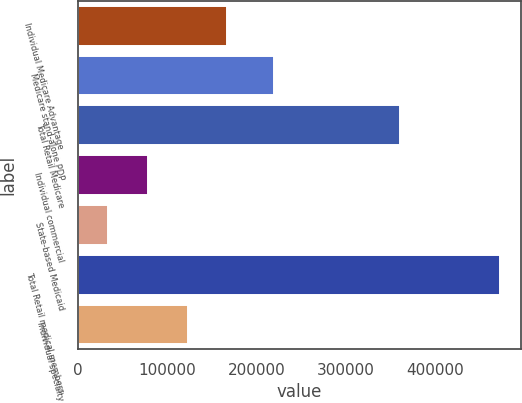<chart> <loc_0><loc_0><loc_500><loc_500><bar_chart><fcel>Individual Medicare Advantage<fcel>Medicare stand-alone PDP<fcel>Total Retail Medicare<fcel>Individual commercial<fcel>State-based Medicaid<fcel>Total Retail medical members<fcel>Individual specialty<nl><fcel>166460<fcel>219000<fcel>360100<fcel>78700<fcel>33400<fcel>472200<fcel>122580<nl></chart> 